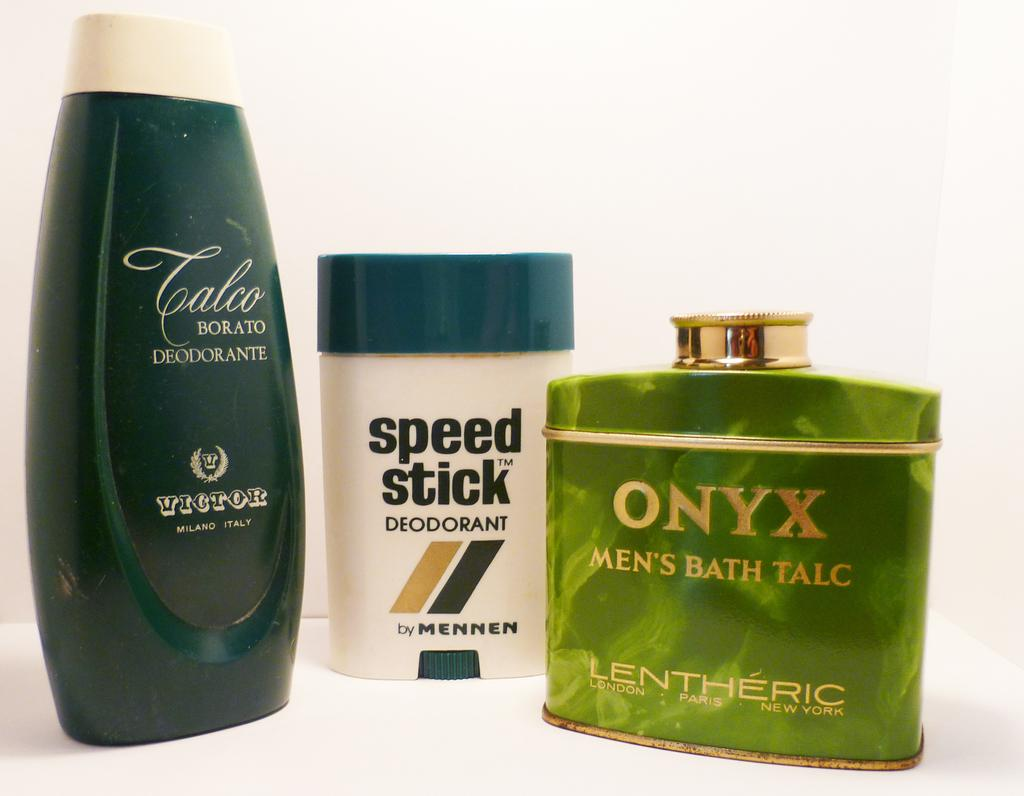<image>
Describe the image concisely. Green bottle of Onyx need to a Speed Stick. 